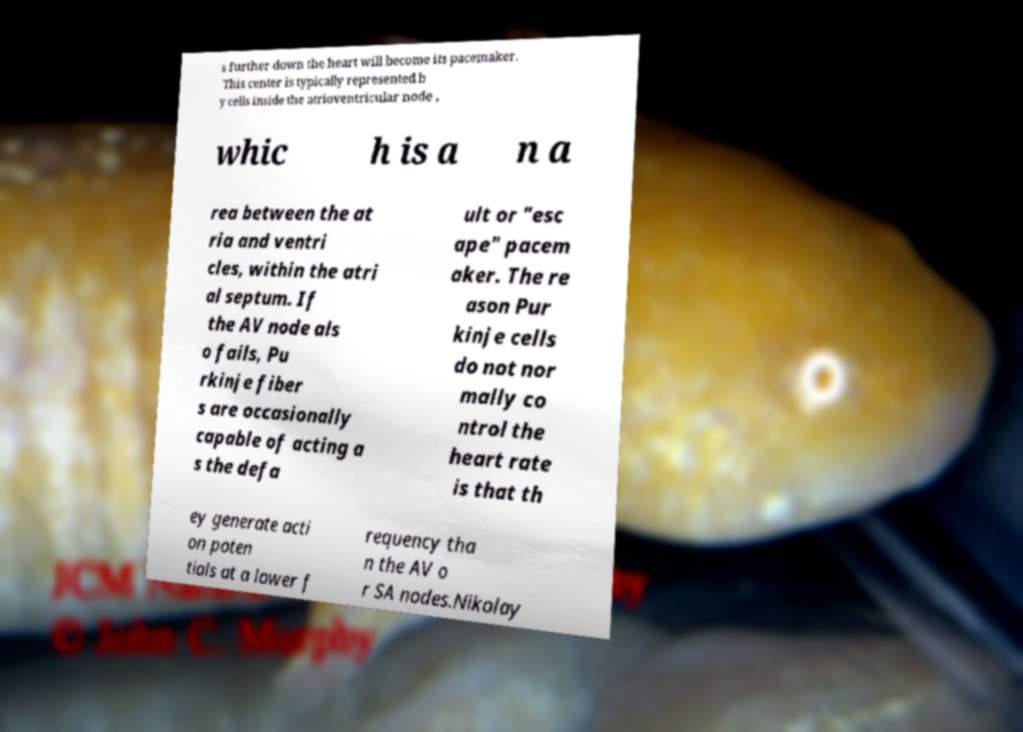Can you accurately transcribe the text from the provided image for me? s further down the heart will become its pacemaker. This center is typically represented b y cells inside the atrioventricular node , whic h is a n a rea between the at ria and ventri cles, within the atri al septum. If the AV node als o fails, Pu rkinje fiber s are occasionally capable of acting a s the defa ult or "esc ape" pacem aker. The re ason Pur kinje cells do not nor mally co ntrol the heart rate is that th ey generate acti on poten tials at a lower f requency tha n the AV o r SA nodes.Nikolay 